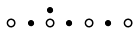<formula> <loc_0><loc_0><loc_500><loc_500>\begin{smallmatrix} & & \bullet \\ \circ & \bullet & \circ & \bullet & \circ & \bullet & \circ & \\ \end{smallmatrix}</formula> 